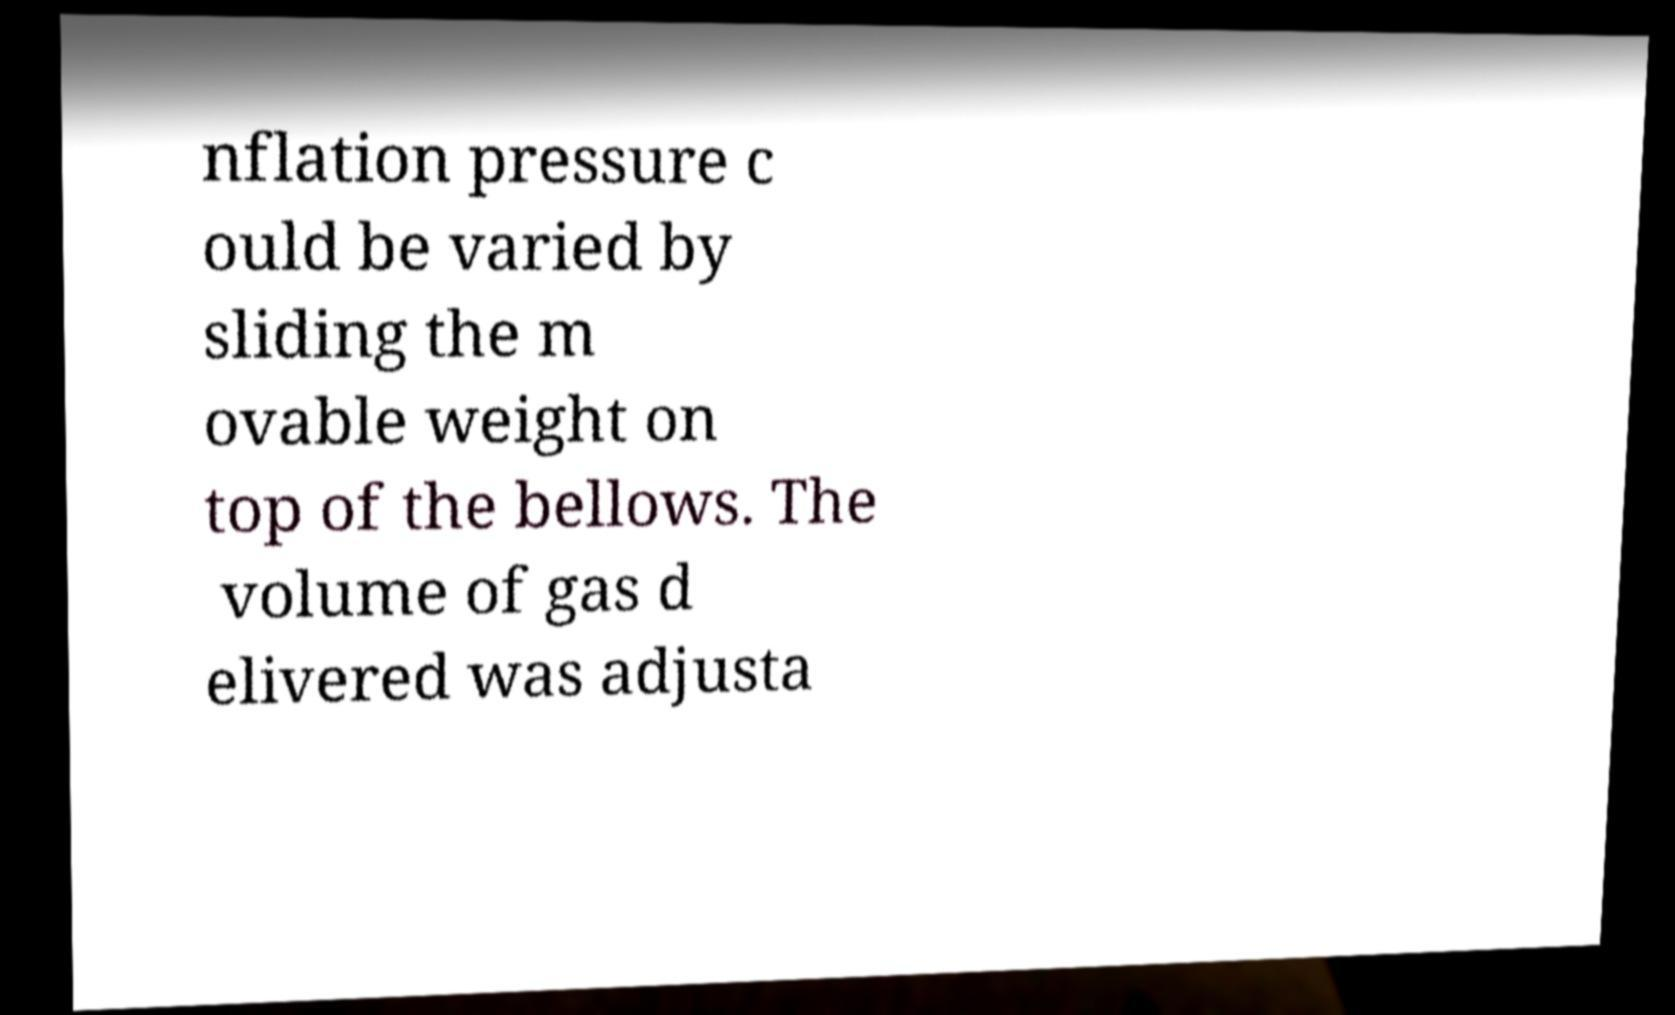Please read and relay the text visible in this image. What does it say? nflation pressure c ould be varied by sliding the m ovable weight on top of the bellows. The volume of gas d elivered was adjusta 